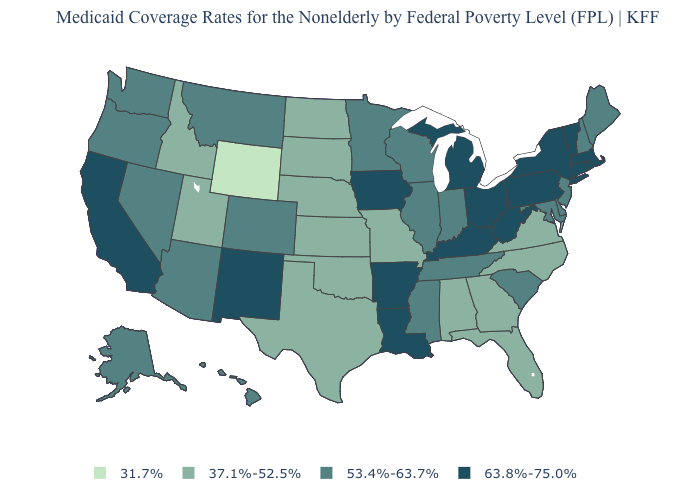What is the value of Montana?
Quick response, please. 53.4%-63.7%. Which states have the highest value in the USA?
Write a very short answer. Arkansas, California, Connecticut, Iowa, Kentucky, Louisiana, Massachusetts, Michigan, New Mexico, New York, Ohio, Pennsylvania, Rhode Island, Vermont, West Virginia. What is the value of Pennsylvania?
Give a very brief answer. 63.8%-75.0%. Which states have the lowest value in the Northeast?
Give a very brief answer. Maine, New Hampshire, New Jersey. Which states have the lowest value in the USA?
Short answer required. Wyoming. Does Kansas have the highest value in the MidWest?
Quick response, please. No. Among the states that border Missouri , does Kentucky have the lowest value?
Quick response, please. No. Among the states that border North Dakota , which have the highest value?
Short answer required. Minnesota, Montana. Name the states that have a value in the range 37.1%-52.5%?
Concise answer only. Alabama, Florida, Georgia, Idaho, Kansas, Missouri, Nebraska, North Carolina, North Dakota, Oklahoma, South Dakota, Texas, Utah, Virginia. Name the states that have a value in the range 63.8%-75.0%?
Short answer required. Arkansas, California, Connecticut, Iowa, Kentucky, Louisiana, Massachusetts, Michigan, New Mexico, New York, Ohio, Pennsylvania, Rhode Island, Vermont, West Virginia. What is the value of Alabama?
Be succinct. 37.1%-52.5%. Name the states that have a value in the range 37.1%-52.5%?
Write a very short answer. Alabama, Florida, Georgia, Idaho, Kansas, Missouri, Nebraska, North Carolina, North Dakota, Oklahoma, South Dakota, Texas, Utah, Virginia. Does Nebraska have the highest value in the USA?
Write a very short answer. No. Does Delaware have the lowest value in the South?
Quick response, please. No. Does Florida have the highest value in the South?
Quick response, please. No. 